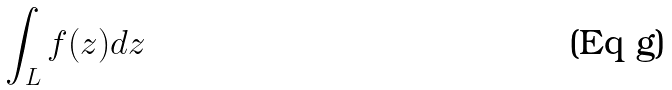<formula> <loc_0><loc_0><loc_500><loc_500>\int _ { L } f ( z ) d z</formula> 